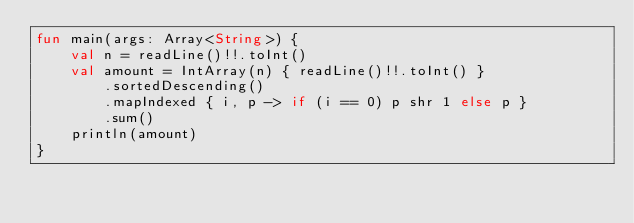<code> <loc_0><loc_0><loc_500><loc_500><_Kotlin_>fun main(args: Array<String>) {
    val n = readLine()!!.toInt()
    val amount = IntArray(n) { readLine()!!.toInt() }
        .sortedDescending()
        .mapIndexed { i, p -> if (i == 0) p shr 1 else p }
        .sum()
    println(amount)
}
</code> 